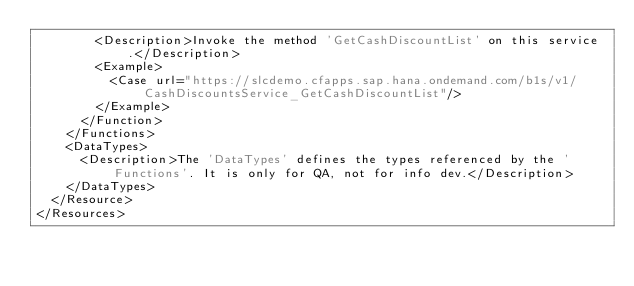Convert code to text. <code><loc_0><loc_0><loc_500><loc_500><_XML_>				<Description>Invoke the method 'GetCashDiscountList' on this service.</Description>
				<Example>
					<Case url="https://slcdemo.cfapps.sap.hana.ondemand.com/b1s/v1/CashDiscountsService_GetCashDiscountList"/>
				</Example>
			</Function>
		</Functions>
		<DataTypes>
			<Description>The 'DataTypes' defines the types referenced by the 'Functions'. It is only for QA, not for info dev.</Description>
		</DataTypes>
	</Resource>
</Resources>
</code> 